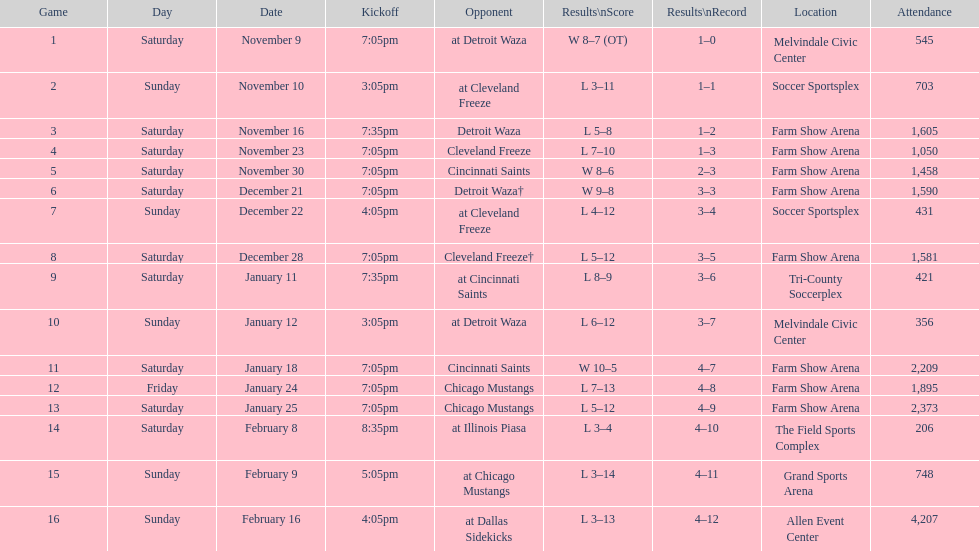Which adversary is mentioned after cleveland freeze in the chart? Detroit Waza. 